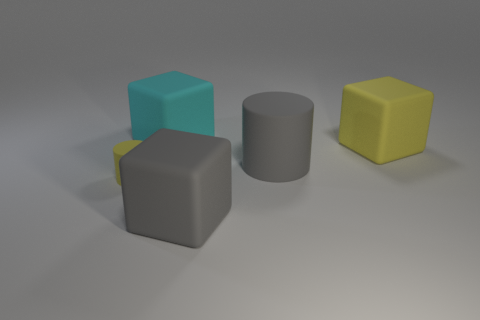Subtract all gray blocks. How many blocks are left? 2 Add 2 big yellow metallic spheres. How many objects exist? 7 Subtract all gray cylinders. How many cylinders are left? 1 Add 3 large blocks. How many large blocks are left? 6 Add 2 cyan cubes. How many cyan cubes exist? 3 Subtract 0 red balls. How many objects are left? 5 Subtract all blocks. How many objects are left? 2 Subtract all red blocks. Subtract all cyan cylinders. How many blocks are left? 3 Subtract all big cyan metal things. Subtract all big gray objects. How many objects are left? 3 